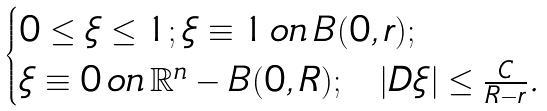<formula> <loc_0><loc_0><loc_500><loc_500>\begin{cases} 0 \leq \xi \leq 1 ; \xi \equiv 1 \, o n \, B ( 0 , r ) ; \\ \xi \equiv 0 \, o n \, \mathbb { R } ^ { n } - B ( 0 , R ) ; \ \ | D \xi | \leq \frac { C } { R - r } . \end{cases}</formula> 